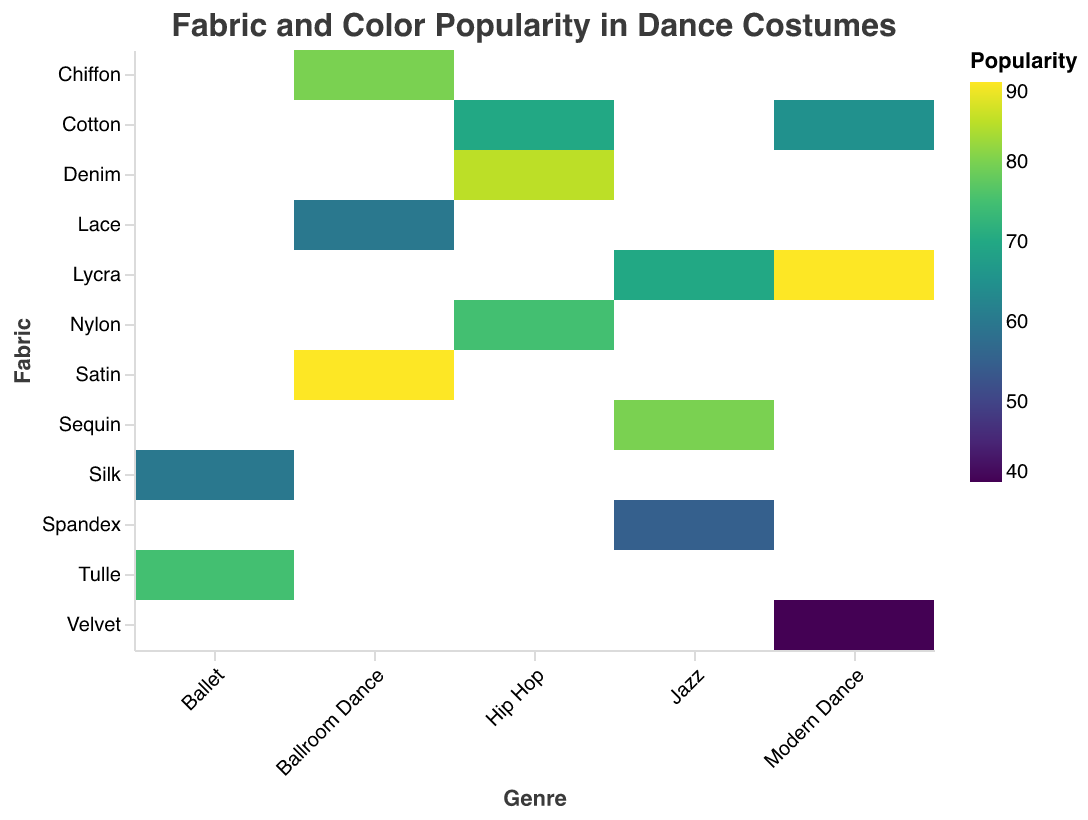What is the most popular dance genre for the fabric Lycra? To find this, locate the fabric Lycra on the y-axis and identify the dance genres associated with it. Modern Dance and Jazz use Lycra with popularity values of 90 and 70, respectively. Modern Dance has the higher value.
Answer: Modern Dance Which color is most popular for Ballet costumes? Look for the genre Ballet on the x-axis and compare the popularity values for each color. The colors are White (85), Pink (75), and White again (60). White (85) is the highest.
Answer: White What is the average popularity for Hip Hop costumes across all fabrics? Locate all data points for Hip Hop on the x-axis. The popularity values are 85 (Denim), 75 (Nylon), and 70 (Cotton). Sum these values (85 + 75 + 70 = 230) and divide by 3 to get the average.
Answer: 76.67 Which fabric has the lowest popularity in Modern Dance? Locate Modern Dance on the x-axis and look for the lowest popularity value among the fabrics used. The values are Lycra (90), Cotton (65), and Velvet (40). Velvet is the lowest.
Answer: Velvet Compare the popularity of Tulle in Ballet to Velvet in Modern Dance. Which is more popular? Locate the data points for Tulle in Ballet (85, 75) and Velvet in Modern Dance (40). The highest value for Tulle is 85, which is greater than 40 for Velvet.
Answer: Tulle in Ballet What is the most popular fabric-color combination for Ballroom Dance? For the genre Ballroom Dance, check the fabric-color pairs and their popularity values. The pairs are Satin (Red) 90, Chiffon (Blue) 80, and Lace (White) 60. The Satin (Red) combination is the highest.
Answer: Satin (Red) What’s the median popularity value for fabrics used in Jazz costumes? For Jazz, the popularity values are Sequin (80), Lycra (70), and Spandex (55). Arrange them in order: 55, 70, 80. The middle value is 70, which is the median.
Answer: 70 Which genre has the highest popularity overall? Compare the highest popularity values for each genre. Ballet (85), Modern Dance (90), Jazz (80), Hip Hop (85), and Ballroom Dance (90). Both Modern Dance and Ballroom Dance have the highest value of 90.
Answer: Modern Dance and Ballroom Dance How does the popularity of Sequin in Jazz compare to Nylon in Hip Hop? Locate the popularity values for Sequin in Jazz (80) and Nylon in Hip Hop (75). Sequin in Jazz has a higher popularity.
Answer: Sequin in Jazz 